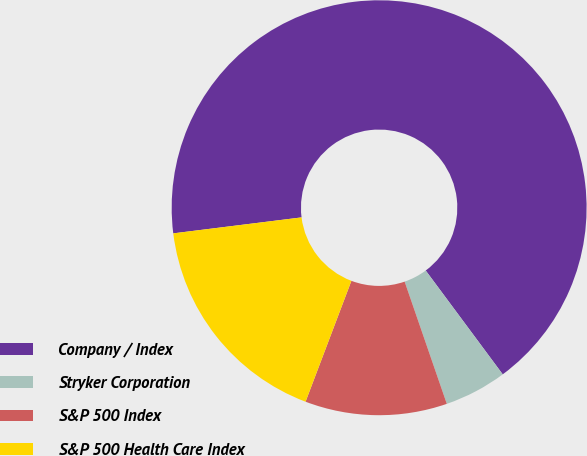Convert chart. <chart><loc_0><loc_0><loc_500><loc_500><pie_chart><fcel>Company / Index<fcel>Stryker Corporation<fcel>S&P 500 Index<fcel>S&P 500 Health Care Index<nl><fcel>66.82%<fcel>4.87%<fcel>11.06%<fcel>17.26%<nl></chart> 